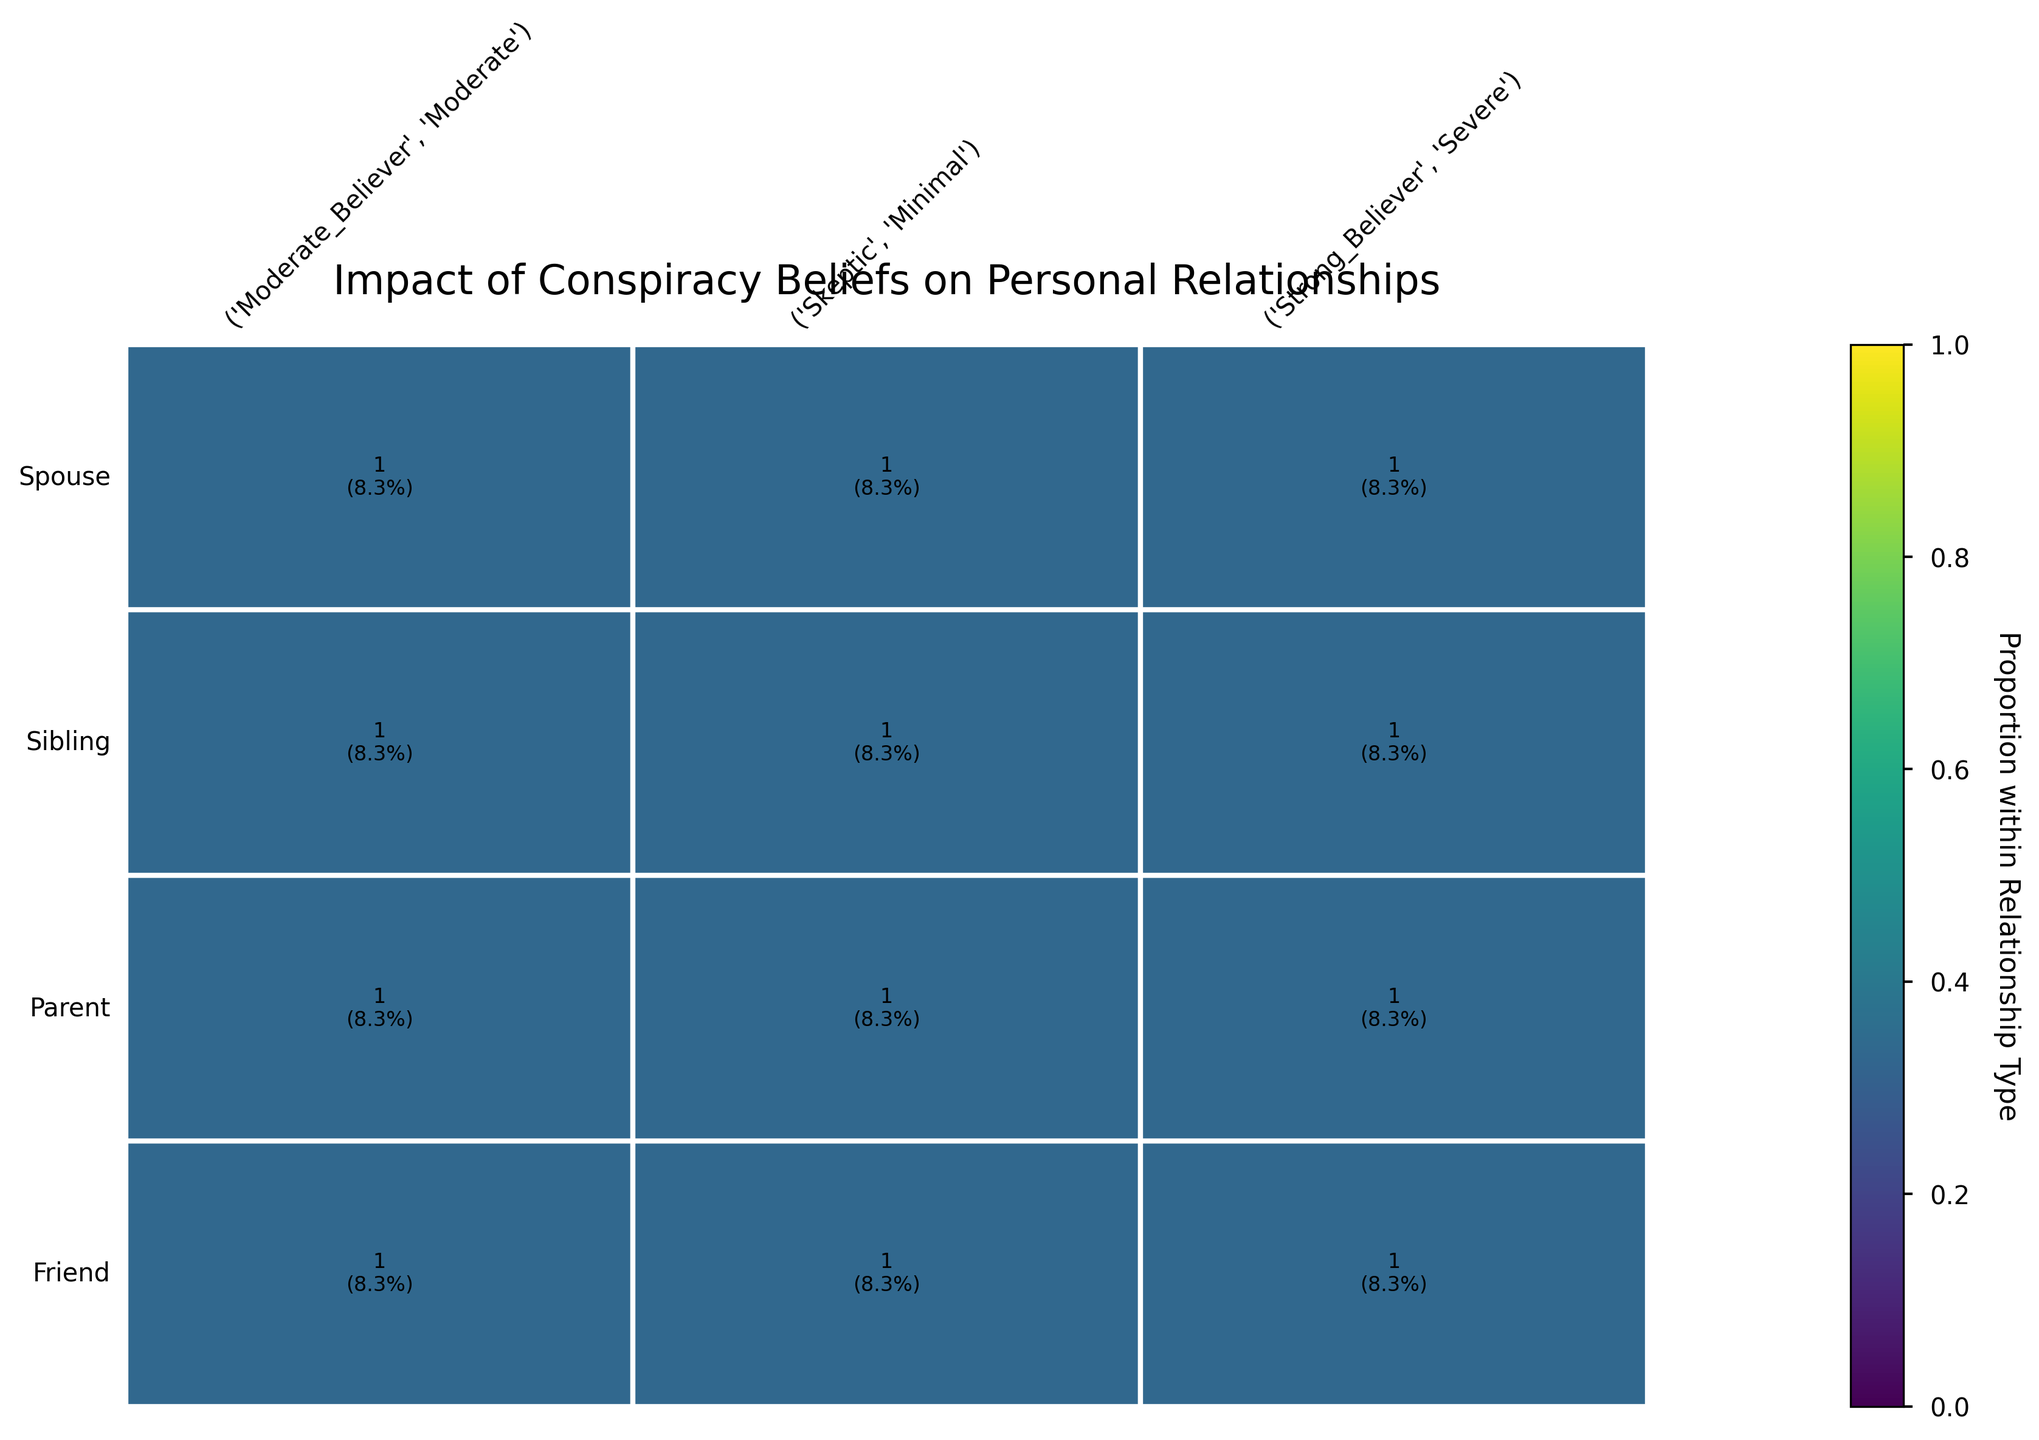What's the title of the plot? The title of the plot is written at the top of the figure.
Answer: "Impact of Conspiracy Beliefs on Personal Relationships" Which belief level among Friends has the highest frequency of severe impact? Look at the section labeled "Friend" and find which belief level has the largest rectangle in the "Severe" column.
Answer: Strong_Believer What is the total frequency of moderate believers across all relationship types? Sum the frequencies of moderate believers from all relationship types as displayed within the rectangles. The frequencies are: 45 (Sibling) + 39 (Parent) + 33 (Spouse) + 52 (Friend). Adding these gives the total frequency.
Answer: 169 Between Siblings and Parents, which group has a higher frequency of minimal impact? Compare the height of "Minimal" rectangles for Siblings and Parents. The height of the "Minimal" impact for Siblings is higher.
Answer: Sibling Which relationship type has the largest total frequency for strong believers? Compare the widths of the "Severe" + other impacts grouped by strong believers for each relationship type and find the largest one.
Answer: Friend For which relationship type does moderate belief lead to the highest impact? Look for the largest rectangle within each relationship type corresponding to moderate belief levels. For each, identify the severity of the impact with the highest frequency.
Answer: Moderate How many severe impact cases are there in total for Parents? Sum all the severe impact cases for Parents: 28 from strong believers.
Answer: 28 How does the frequency of minimal impact among skeptics compare between Siblings and Friends? Compare the height of the "Minimal" rectangles for skeptics in the Sibling and Friend categories. The height is higher for Friends.
Answer: Friends have a higher frequency What proportion of spouses are strong believers experiencing severe impact? Find the number of severe impact cases for strong believers in the Spouse category (21), then divide by the total number of Spouse cases (21+33+56). Calculate the proportion 21 / 110.
Answer: Approximately 19% Which relationship type has the most balanced distribution of impact levels among skeptics? Look for the relationship type where the rectangles corresponding to skeptics have relatively equal heights for minimal impact.
Answer: Sibling 